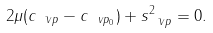Convert formula to latex. <formula><loc_0><loc_0><loc_500><loc_500>2 { \mu } ( c _ { \bar { \ v p } } - c _ { \ v p _ { 0 } } ) + s ^ { 2 } _ { \bar { \ v p } } = 0 .</formula> 